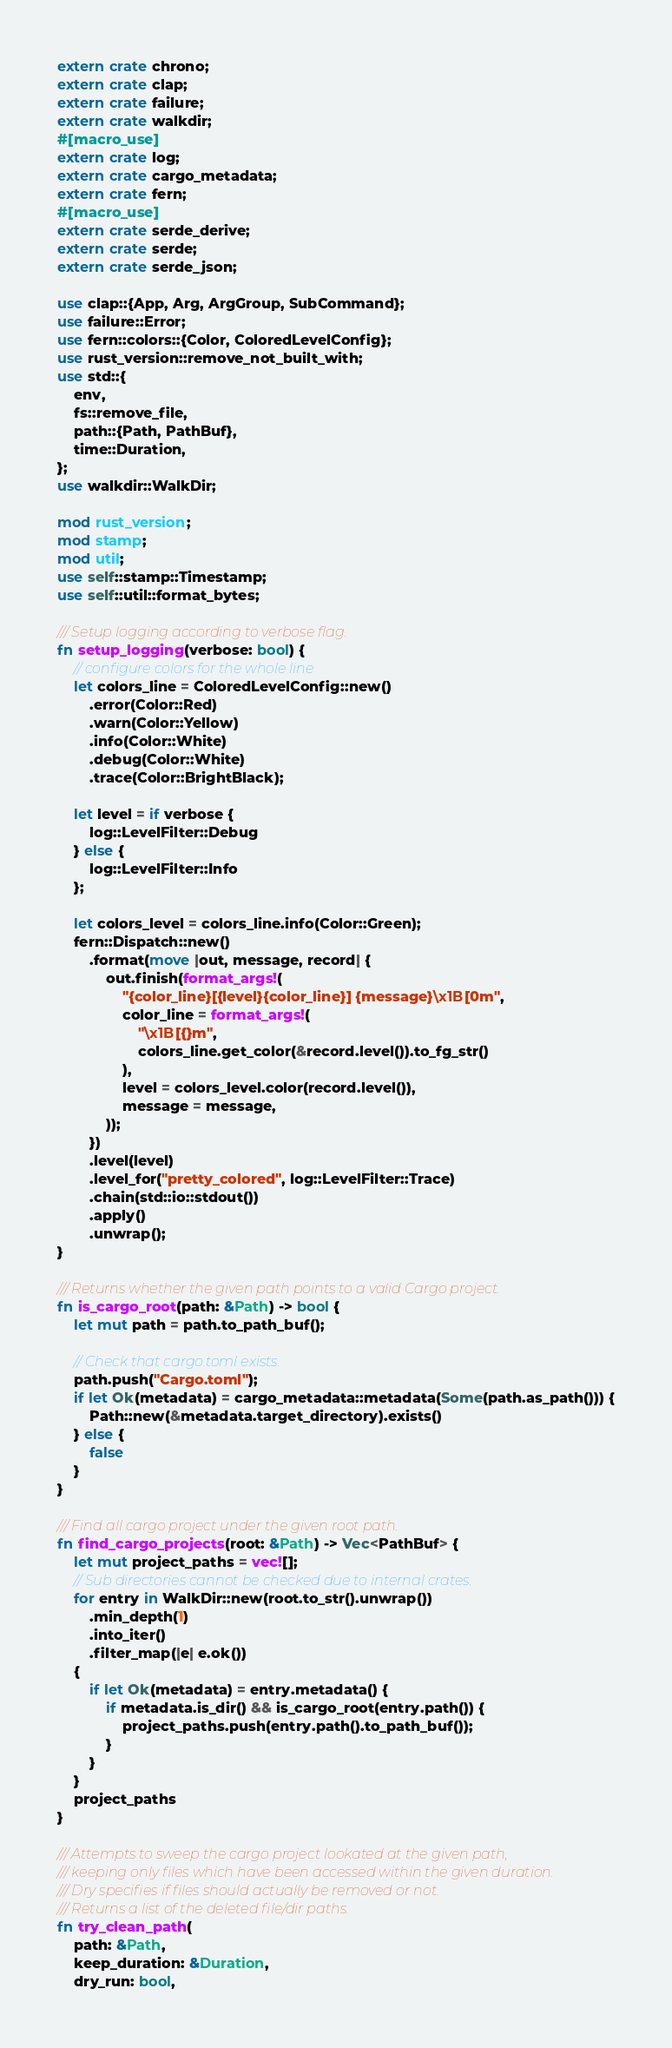Convert code to text. <code><loc_0><loc_0><loc_500><loc_500><_Rust_>extern crate chrono;
extern crate clap;
extern crate failure;
extern crate walkdir;
#[macro_use]
extern crate log;
extern crate cargo_metadata;
extern crate fern;
#[macro_use]
extern crate serde_derive;
extern crate serde;
extern crate serde_json;

use clap::{App, Arg, ArgGroup, SubCommand};
use failure::Error;
use fern::colors::{Color, ColoredLevelConfig};
use rust_version::remove_not_built_with;
use std::{
    env,
    fs::remove_file,
    path::{Path, PathBuf},
    time::Duration,
};
use walkdir::WalkDir;

mod rust_version;
mod stamp;
mod util;
use self::stamp::Timestamp;
use self::util::format_bytes;

/// Setup logging according to verbose flag.
fn setup_logging(verbose: bool) {
    // configure colors for the whole line
    let colors_line = ColoredLevelConfig::new()
        .error(Color::Red)
        .warn(Color::Yellow)
        .info(Color::White)
        .debug(Color::White)
        .trace(Color::BrightBlack);

    let level = if verbose {
        log::LevelFilter::Debug
    } else {
        log::LevelFilter::Info
    };

    let colors_level = colors_line.info(Color::Green);
    fern::Dispatch::new()
        .format(move |out, message, record| {
            out.finish(format_args!(
                "{color_line}[{level}{color_line}] {message}\x1B[0m",
                color_line = format_args!(
                    "\x1B[{}m",
                    colors_line.get_color(&record.level()).to_fg_str()
                ),
                level = colors_level.color(record.level()),
                message = message,
            ));
        })
        .level(level)
        .level_for("pretty_colored", log::LevelFilter::Trace)
        .chain(std::io::stdout())
        .apply()
        .unwrap();
}

/// Returns whether the given path points to a valid Cargo project.
fn is_cargo_root(path: &Path) -> bool {
    let mut path = path.to_path_buf();

    // Check that cargo.toml exists.
    path.push("Cargo.toml");
    if let Ok(metadata) = cargo_metadata::metadata(Some(path.as_path())) {
        Path::new(&metadata.target_directory).exists()
    } else {
        false
    }
}

/// Find all cargo project under the given root path.
fn find_cargo_projects(root: &Path) -> Vec<PathBuf> {
    let mut project_paths = vec![];
    // Sub directories cannot be checked due to internal crates.
    for entry in WalkDir::new(root.to_str().unwrap())
        .min_depth(1)
        .into_iter()
        .filter_map(|e| e.ok())
    {
        if let Ok(metadata) = entry.metadata() {
            if metadata.is_dir() && is_cargo_root(entry.path()) {
                project_paths.push(entry.path().to_path_buf());
            }
        }
    }
    project_paths
}

/// Attempts to sweep the cargo project lookated at the given path,
/// keeping only files which have been accessed within the given duration.
/// Dry specifies if files should actually be removed or not.
/// Returns a list of the deleted file/dir paths.
fn try_clean_path(
    path: &Path,
    keep_duration: &Duration,
    dry_run: bool,</code> 